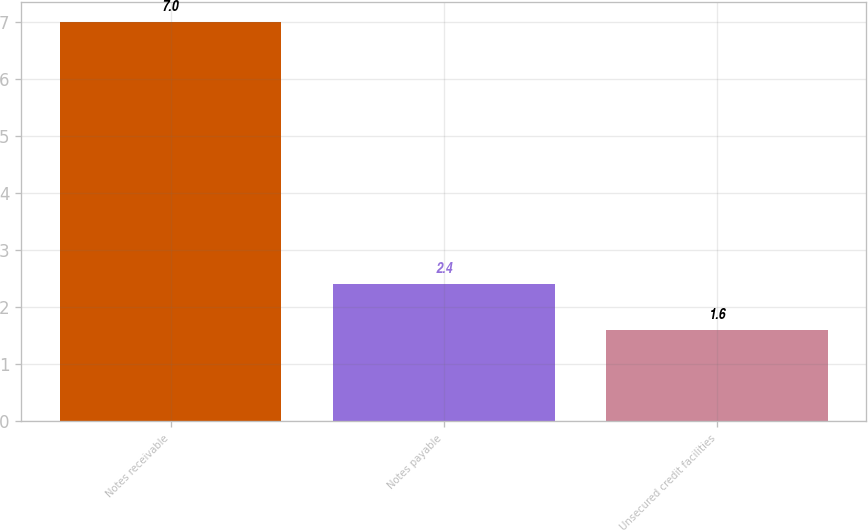<chart> <loc_0><loc_0><loc_500><loc_500><bar_chart><fcel>Notes receivable<fcel>Notes payable<fcel>Unsecured credit facilities<nl><fcel>7<fcel>2.4<fcel>1.6<nl></chart> 